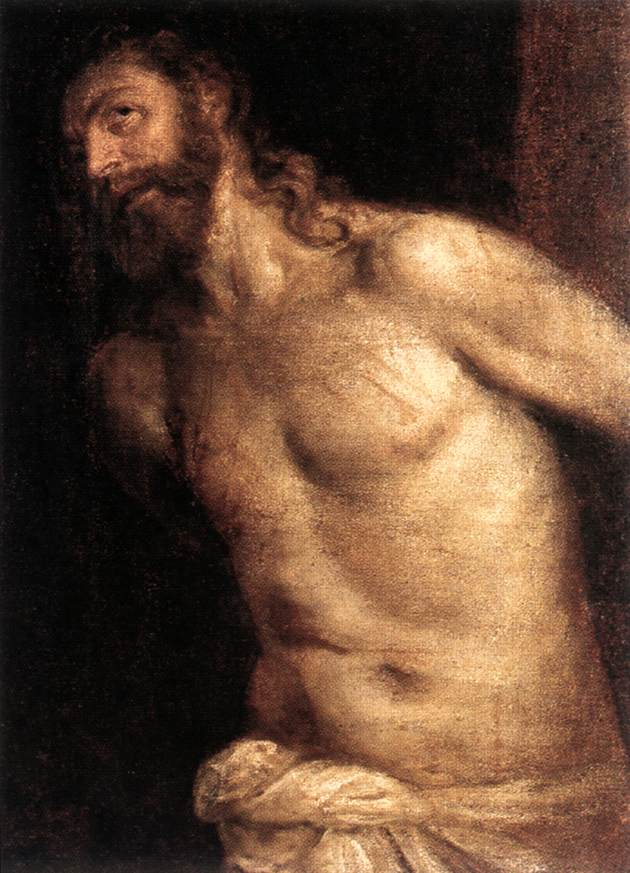Can you provide more context about the historical or cultural significance of this image? This painting is likely from the Baroque era, a period known for dramatic expressions and intricate details in art, roughly spanning from the late 16th century to the early 18th century. Baroque artists often focused on religious themes, aiming to evoke emotional responses from viewers. The figure could represent a biblical character, such as Christ or a martyred saint, common subjects in Baroque religious art. The use of chiaroscuro (light and shadow) not only emphasizes his physical form but also symbolizes spiritual enlightenment against a backdrop of darkness and suffering. This style and choice of subject matter reflect the period's combined focus on human realism, emotional depth, and spiritual contemplation. What emotions or themes does the artist convey through this artwork? The artist conveys a sense of solemnity, suffering, and perhaps a hint of transcendence. The man's pained expression and tense body suggest physical suffering, while the soft, almost divine light illuminating his form could indicate hope or spiritual salvation. The dark background starkly contrasts with his illuminated body, emphasizing themes of suffering and redemption. This interplay of light and dark highlights inner turmoil and the struggle between despair and hope, which is a potent theme in Baroque religious art. The white cloth, a symbol of purity or sacrifice, further intensifies the narrative of suffering for a greater cause or faith.  Imagine the figure suddenly coming to life. What would his first words be? "Why have you forsaken me?" might be his initial words, reflecting an expression of anguish, quest for meaning, and longing for solace or deliverance from his suffering. 